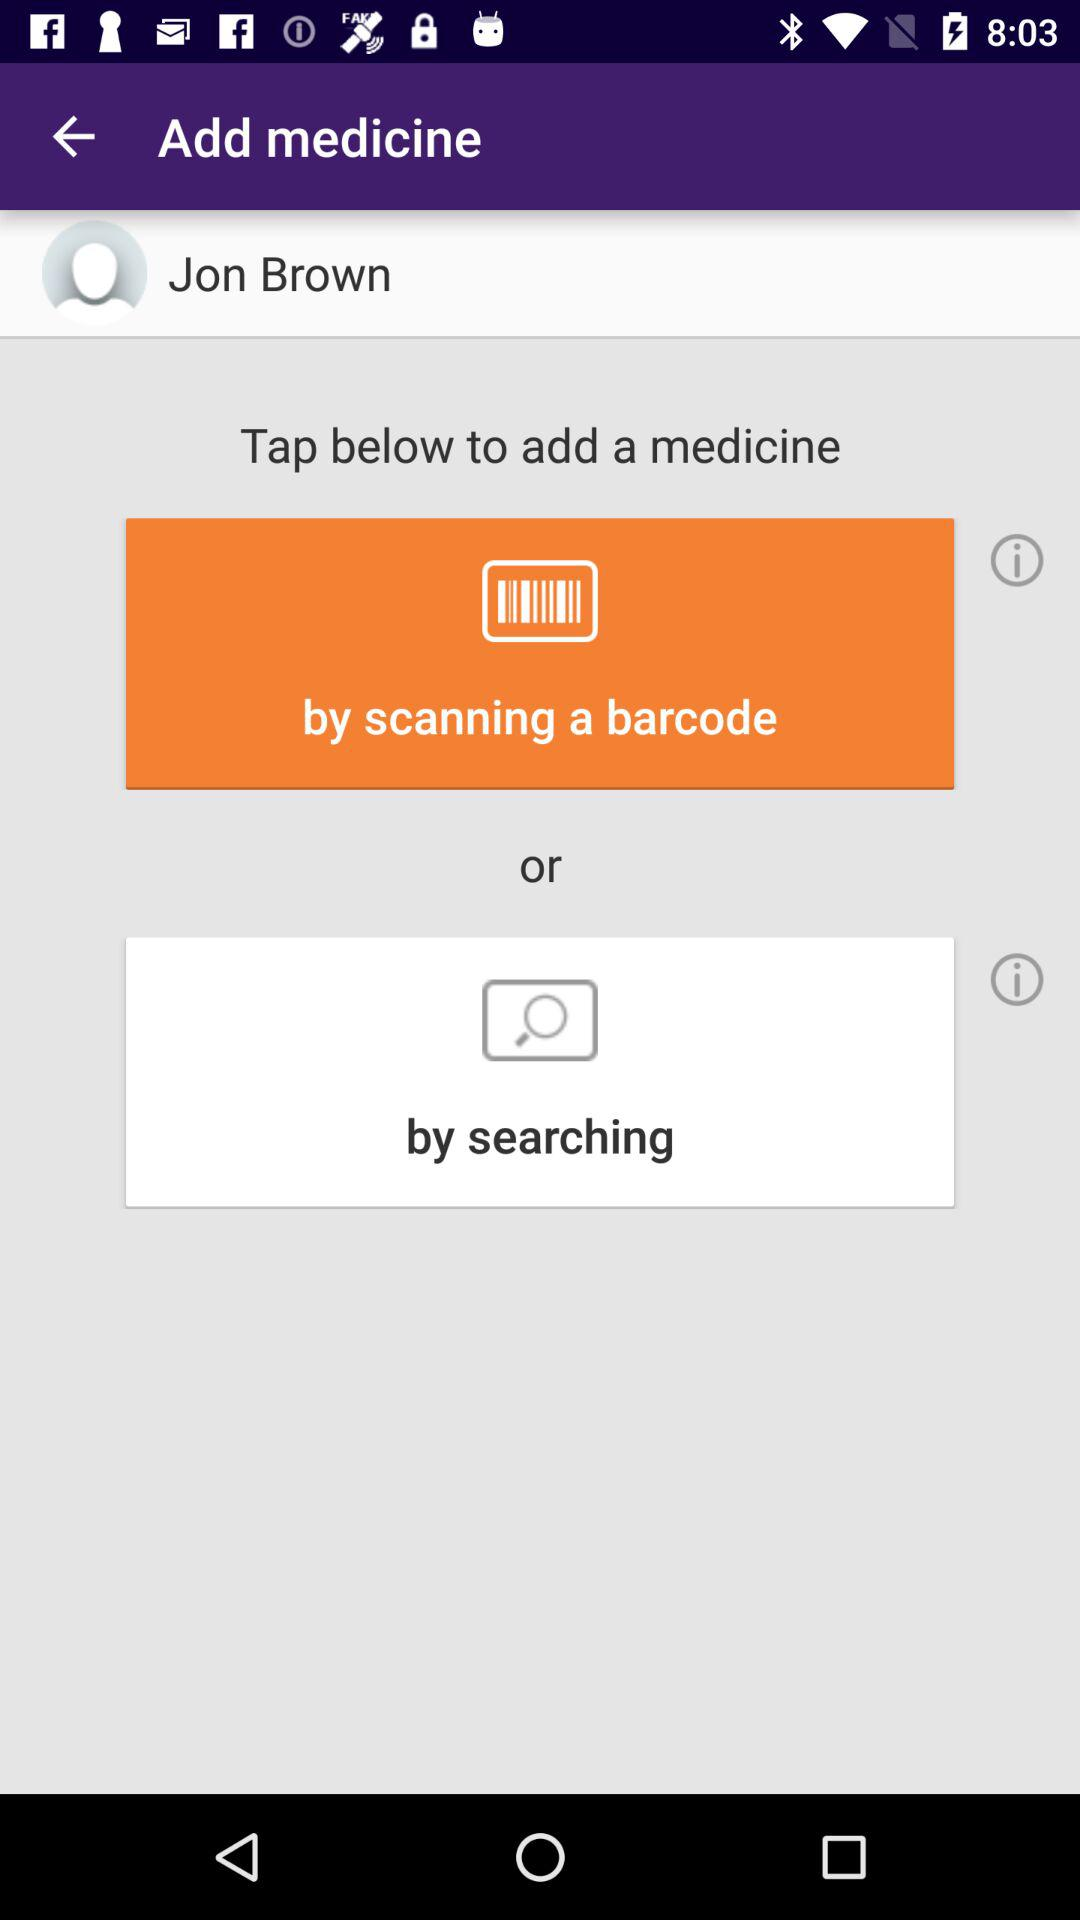Which barcodes can be scanned?
When the provided information is insufficient, respond with <no answer>. <no answer> 